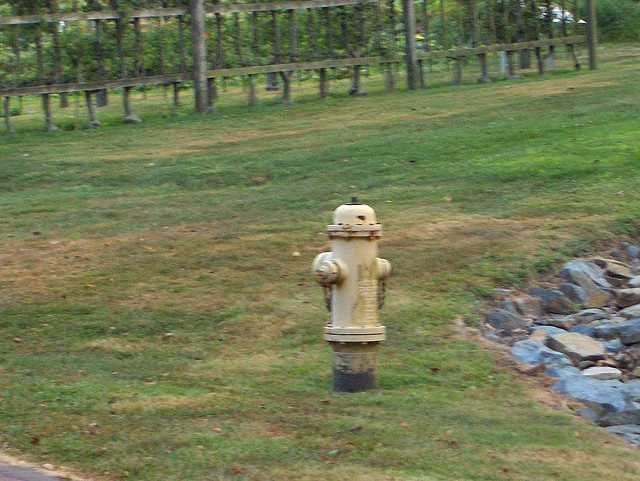Describe the objects in this image and their specific colors. I can see a fire hydrant in darkgreen, darkgray, tan, and gray tones in this image. 